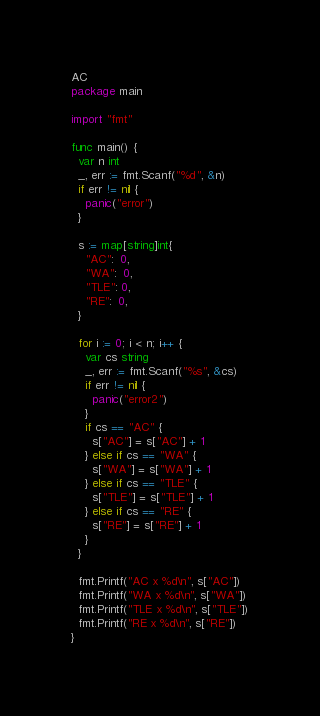<code> <loc_0><loc_0><loc_500><loc_500><_Go_>AC
package main

import "fmt"

func main() {
  var n int
  _, err := fmt.Scanf("%d", &n)
  if err != nil {
    panic("error")
  }

  s := map[string]int{
    "AC":  0,
    "WA":  0,
    "TLE": 0,
    "RE":  0,
  }

  for i := 0; i < n; i++ {
    var cs string
    _, err := fmt.Scanf("%s", &cs)
    if err != nil {
      panic("error2")
    }
    if cs == "AC" {
      s["AC"] = s["AC"] + 1
    } else if cs == "WA" {
      s["WA"] = s["WA"] + 1
    } else if cs == "TLE" {
      s["TLE"] = s["TLE"] + 1
    } else if cs == "RE" {
      s["RE"] = s["RE"] + 1
    }
  }

  fmt.Printf("AC x %d\n", s["AC"])
  fmt.Printf("WA x %d\n", s["WA"])
  fmt.Printf("TLE x %d\n", s["TLE"])
  fmt.Printf("RE x %d\n", s["RE"])
}</code> 